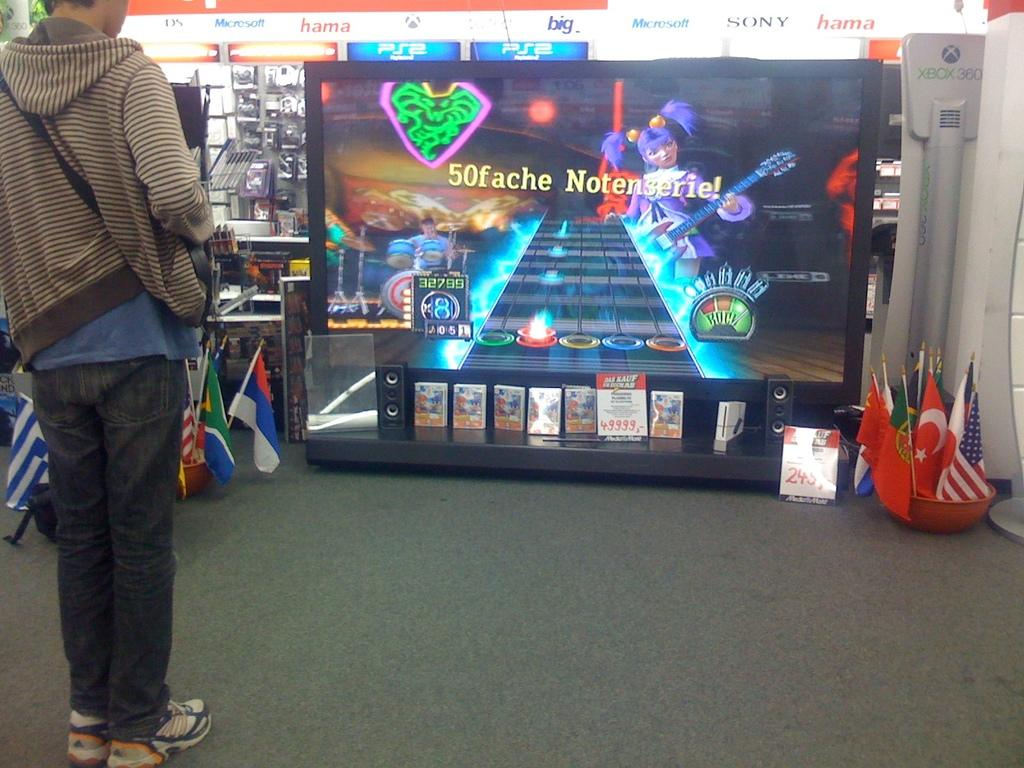What is the primary subject in the image? There is a person standing in the image. Where is the person standing? The person is standing on the floor. What else can be seen in the image besides the person? There are flags and a monitor in the image. Are there any other objects present in the image? Yes, there are some objects in the image. What country is the stranger from in the image? There is no stranger present in the image, and therefore no information about their country of origin can be provided. 